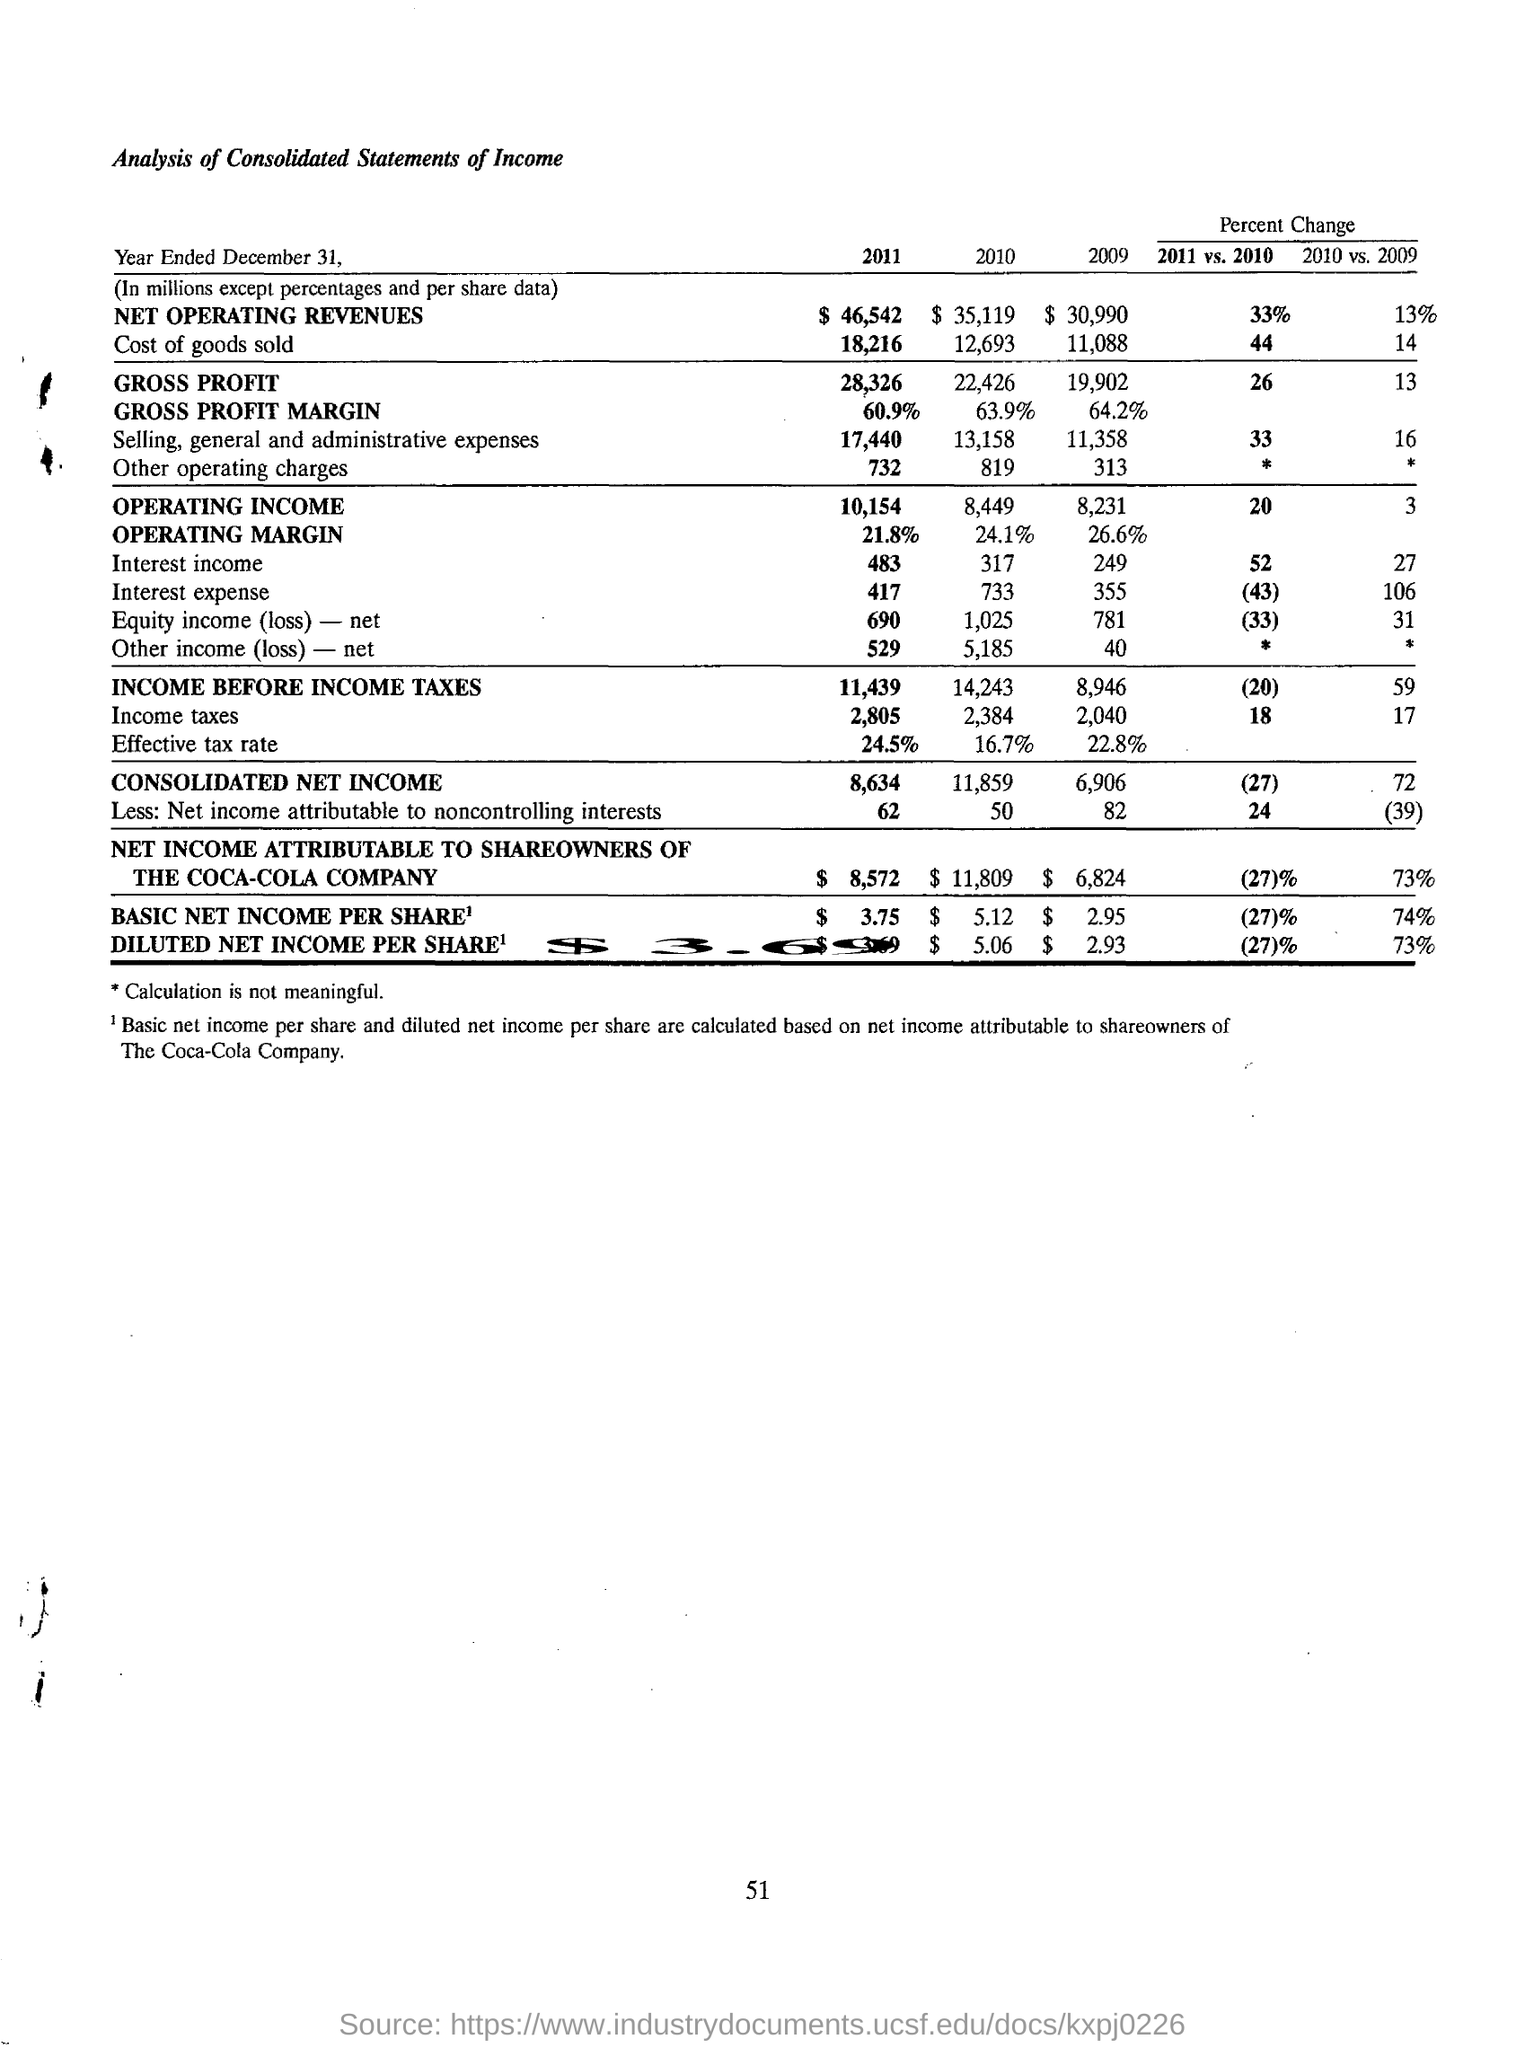What is the income before income taxes for the year 2011?
Provide a succinct answer. 11,439. What is the consolidated net income for the year 2011?
Offer a terse response. 8,634. What is the basic net income per share for the year 2011?
Ensure brevity in your answer.  $3.75. What is the diluted net income per share for the year 2010?
Give a very brief answer. $5.06. What is the amount of net operating revenues for the year 2011?
Your answer should be compact. $46,542. What is the effective tax rate for the year 2011?
Provide a succinct answer. 24.5%. What is the net income attributable to the shareowners of the Cola-Cola Company for the year 2010?
Your response must be concise. $11,809. What kind of analysis is done here?
Give a very brief answer. CONSOLIDATED STATEMENTS OF INCOME. What is the gross profit margin for the year 2009?
Make the answer very short. 64.2%. 